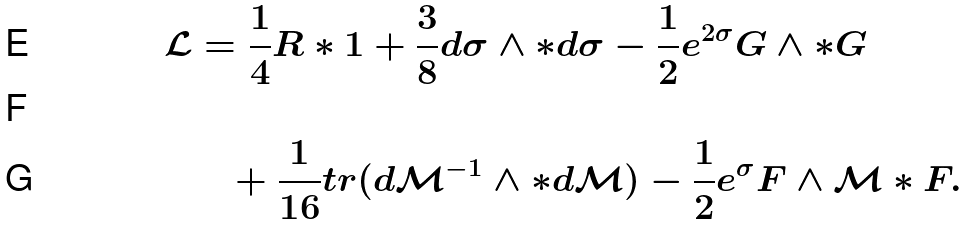Convert formula to latex. <formula><loc_0><loc_0><loc_500><loc_500>\mathcal { L } & = \frac { 1 } { 4 } R \ast 1 + \frac { 3 } { 8 } d \sigma \wedge \ast d \sigma - \frac { 1 } { 2 } e ^ { 2 \sigma } G \wedge \ast G \\ \\ & \quad + \frac { 1 } { 1 6 } t r ( d \mathcal { M } ^ { - 1 } \wedge \ast d \mathcal { M } ) - \frac { 1 } { 2 } e ^ { \sigma } F \wedge \mathcal { M } \ast F .</formula> 